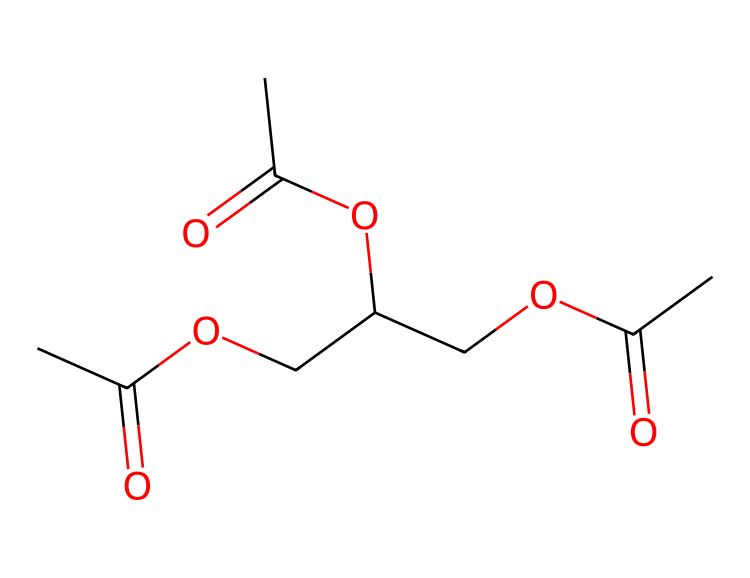What is the name of this ester? The structure corresponds to triacetin, which is derived from glycerol and acetic acid. The three acetate groups are visible in the molecular structure.
Answer: triacetin How many carbon atoms are in triacetin? By analyzing the SMILES representation, we count the number of 'C' characters, which represent carbon atoms. There are nine carbon atoms in total.
Answer: nine How many ester groups does triacetin have? The presence of the ester functional group (-COO-) can be identified in the chemical structure. Triacetin has three ester groups, as it contains three acetic acid moieties linked to glycerol.
Answer: three What is the functional group present in this compound? Analyzing the structure, the functional group present is the ester group, characterized by the carbonyl (C=O) and ether (C-O) connections.
Answer: ester What is the molecular formula of triacetin? The molecular formula can be deduced by counting the number of each type of atom present in the structure as represented in the SMILES. The resulting formula is C9H16O5.
Answer: C9H16O5 How does the structure of triacetin influence its solubility? The structure includes multiple polar ester groups which enhance the molecule's solubility in polar solvents, such as water, due to hydrogen bonding capabilities.
Answer: enhances solubility What type of reactions can triacetin undergo due to its structure? Triacetin can undergo hydrolysis reactions where the ester bonds can be broken down by water in the presence of an acid or base, converting it to glycerol and acetic acid.
Answer: hydrolysis reactions 